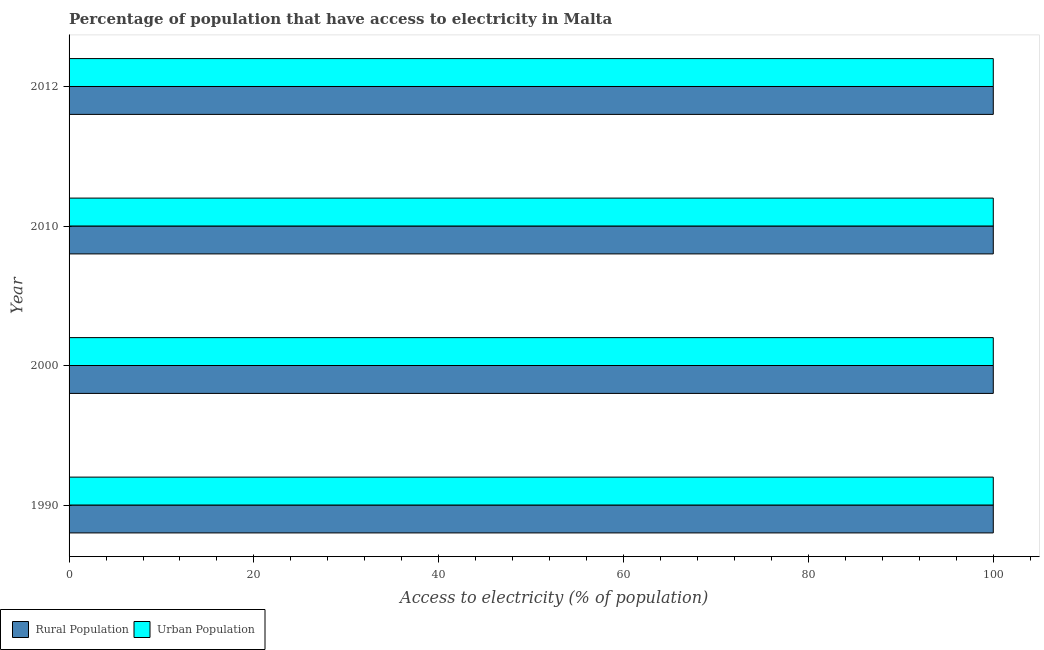How many groups of bars are there?
Keep it short and to the point. 4. Are the number of bars on each tick of the Y-axis equal?
Your answer should be compact. Yes. What is the label of the 1st group of bars from the top?
Offer a very short reply. 2012. In how many cases, is the number of bars for a given year not equal to the number of legend labels?
Offer a terse response. 0. What is the percentage of rural population having access to electricity in 2010?
Provide a short and direct response. 100. Across all years, what is the maximum percentage of rural population having access to electricity?
Offer a very short reply. 100. Across all years, what is the minimum percentage of urban population having access to electricity?
Ensure brevity in your answer.  100. What is the total percentage of urban population having access to electricity in the graph?
Offer a terse response. 400. What is the difference between the percentage of rural population having access to electricity in 2010 and that in 2012?
Offer a very short reply. 0. What is the difference between the percentage of urban population having access to electricity in 2000 and the percentage of rural population having access to electricity in 1990?
Keep it short and to the point. 0. What is the average percentage of urban population having access to electricity per year?
Ensure brevity in your answer.  100. In how many years, is the percentage of urban population having access to electricity greater than 28 %?
Offer a very short reply. 4. What is the ratio of the percentage of rural population having access to electricity in 1990 to that in 2012?
Provide a succinct answer. 1. Is the percentage of rural population having access to electricity in 2010 less than that in 2012?
Offer a very short reply. No. Is the difference between the percentage of rural population having access to electricity in 1990 and 2000 greater than the difference between the percentage of urban population having access to electricity in 1990 and 2000?
Offer a terse response. No. What is the difference between the highest and the second highest percentage of rural population having access to electricity?
Your response must be concise. 0. What is the difference between the highest and the lowest percentage of urban population having access to electricity?
Your response must be concise. 0. What does the 2nd bar from the top in 2000 represents?
Make the answer very short. Rural Population. What does the 1st bar from the bottom in 2000 represents?
Your response must be concise. Rural Population. How many bars are there?
Keep it short and to the point. 8. Does the graph contain any zero values?
Make the answer very short. No. Does the graph contain grids?
Keep it short and to the point. No. How many legend labels are there?
Make the answer very short. 2. What is the title of the graph?
Your answer should be very brief. Percentage of population that have access to electricity in Malta. What is the label or title of the X-axis?
Provide a succinct answer. Access to electricity (% of population). What is the label or title of the Y-axis?
Offer a very short reply. Year. What is the Access to electricity (% of population) in Rural Population in 1990?
Your answer should be compact. 100. What is the Access to electricity (% of population) of Urban Population in 1990?
Offer a terse response. 100. What is the Access to electricity (% of population) in Rural Population in 2000?
Your response must be concise. 100. What is the Access to electricity (% of population) of Rural Population in 2010?
Give a very brief answer. 100. What is the Access to electricity (% of population) of Urban Population in 2012?
Make the answer very short. 100. Across all years, what is the maximum Access to electricity (% of population) in Urban Population?
Keep it short and to the point. 100. What is the total Access to electricity (% of population) of Rural Population in the graph?
Your answer should be very brief. 400. What is the total Access to electricity (% of population) in Urban Population in the graph?
Offer a very short reply. 400. What is the difference between the Access to electricity (% of population) of Rural Population in 1990 and that in 2000?
Make the answer very short. 0. What is the difference between the Access to electricity (% of population) of Rural Population in 2000 and that in 2010?
Your answer should be very brief. 0. What is the difference between the Access to electricity (% of population) in Rural Population in 2010 and that in 2012?
Offer a terse response. 0. What is the difference between the Access to electricity (% of population) of Urban Population in 2010 and that in 2012?
Provide a short and direct response. 0. What is the difference between the Access to electricity (% of population) of Rural Population in 1990 and the Access to electricity (% of population) of Urban Population in 2000?
Provide a short and direct response. 0. What is the difference between the Access to electricity (% of population) of Rural Population in 1990 and the Access to electricity (% of population) of Urban Population in 2010?
Ensure brevity in your answer.  0. What is the difference between the Access to electricity (% of population) of Rural Population in 1990 and the Access to electricity (% of population) of Urban Population in 2012?
Your response must be concise. 0. What is the difference between the Access to electricity (% of population) in Rural Population in 2000 and the Access to electricity (% of population) in Urban Population in 2010?
Your response must be concise. 0. What is the difference between the Access to electricity (% of population) in Rural Population in 2000 and the Access to electricity (% of population) in Urban Population in 2012?
Your answer should be compact. 0. What is the difference between the Access to electricity (% of population) of Rural Population in 2010 and the Access to electricity (% of population) of Urban Population in 2012?
Provide a short and direct response. 0. What is the ratio of the Access to electricity (% of population) in Rural Population in 1990 to that in 2000?
Provide a short and direct response. 1. What is the ratio of the Access to electricity (% of population) of Urban Population in 1990 to that in 2010?
Keep it short and to the point. 1. What is the ratio of the Access to electricity (% of population) of Rural Population in 2000 to that in 2010?
Provide a succinct answer. 1. What is the ratio of the Access to electricity (% of population) in Urban Population in 2000 to that in 2010?
Provide a short and direct response. 1. What is the ratio of the Access to electricity (% of population) in Urban Population in 2000 to that in 2012?
Your answer should be very brief. 1. What is the ratio of the Access to electricity (% of population) of Rural Population in 2010 to that in 2012?
Ensure brevity in your answer.  1. What is the ratio of the Access to electricity (% of population) of Urban Population in 2010 to that in 2012?
Ensure brevity in your answer.  1. What is the difference between the highest and the second highest Access to electricity (% of population) of Rural Population?
Make the answer very short. 0. What is the difference between the highest and the second highest Access to electricity (% of population) of Urban Population?
Ensure brevity in your answer.  0. What is the difference between the highest and the lowest Access to electricity (% of population) of Rural Population?
Give a very brief answer. 0. 